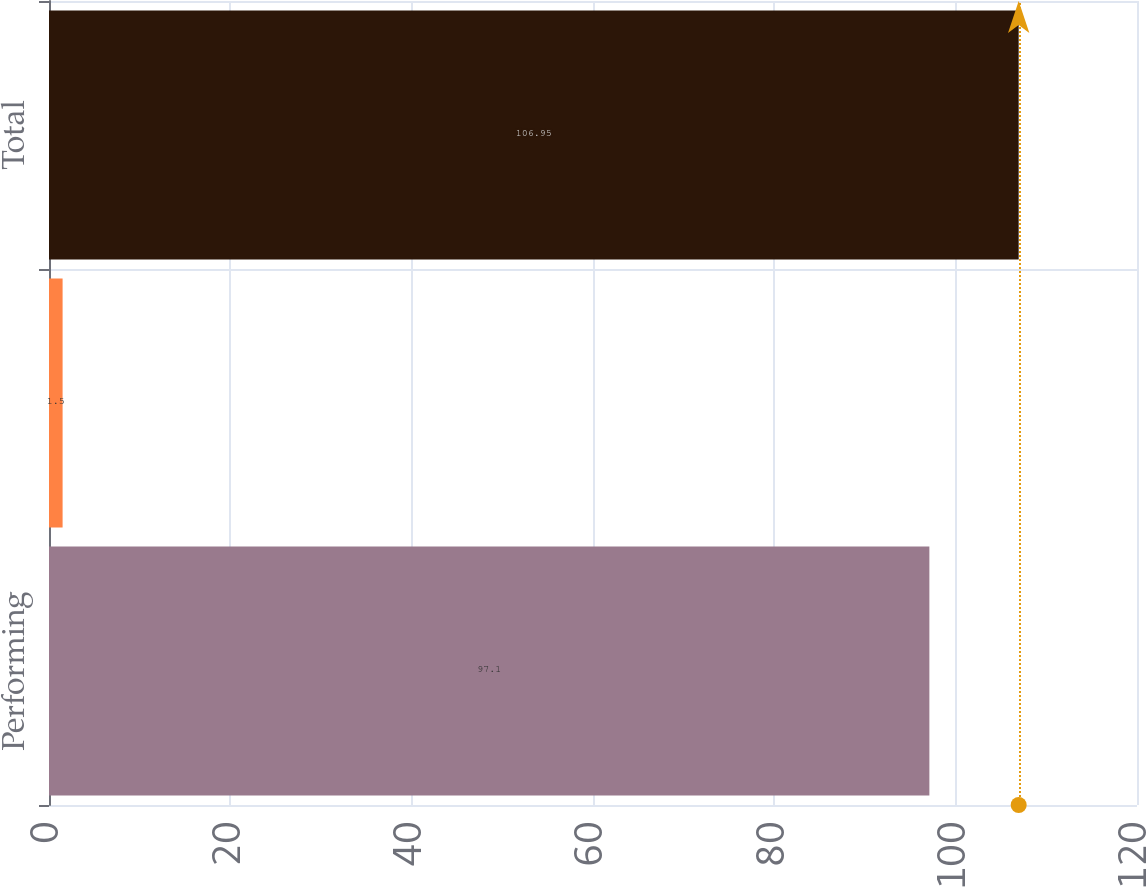Convert chart. <chart><loc_0><loc_0><loc_500><loc_500><bar_chart><fcel>Performing<fcel>Delinquent or under<fcel>Total<nl><fcel>97.1<fcel>1.5<fcel>106.95<nl></chart> 